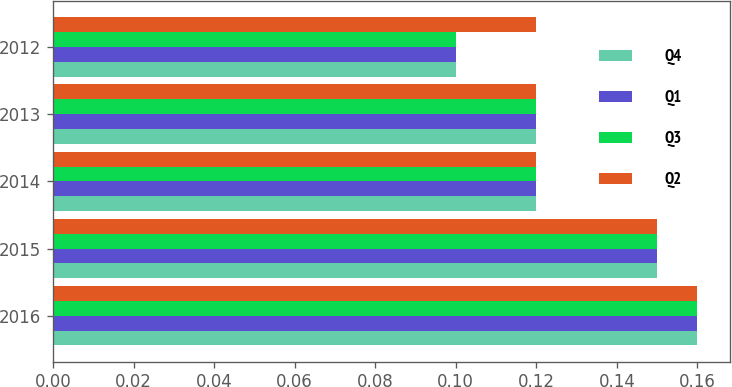Convert chart to OTSL. <chart><loc_0><loc_0><loc_500><loc_500><stacked_bar_chart><ecel><fcel>2016<fcel>2015<fcel>2014<fcel>2013<fcel>2012<nl><fcel>Q4<fcel>0.16<fcel>0.15<fcel>0.12<fcel>0.12<fcel>0.1<nl><fcel>Q1<fcel>0.16<fcel>0.15<fcel>0.12<fcel>0.12<fcel>0.1<nl><fcel>Q3<fcel>0.16<fcel>0.15<fcel>0.12<fcel>0.12<fcel>0.1<nl><fcel>Q2<fcel>0.16<fcel>0.15<fcel>0.12<fcel>0.12<fcel>0.12<nl></chart> 